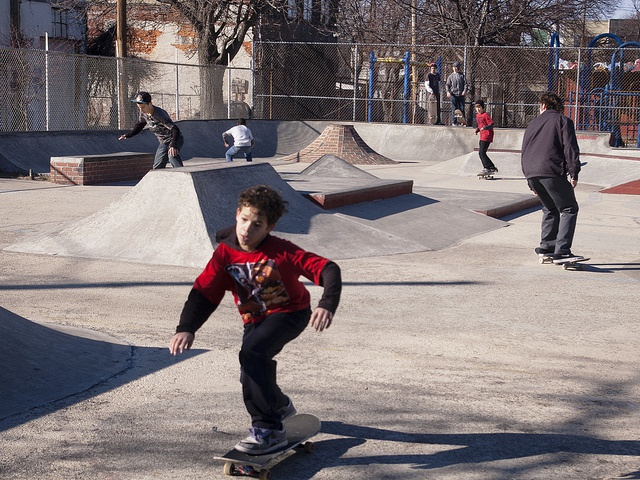Describe the objects in this image and their specific colors. I can see people in gray, black, maroon, and brown tones, people in gray, black, and darkgray tones, people in gray, black, and darkgray tones, skateboard in gray, black, and darkgray tones, and people in gray, black, and lavender tones in this image. 